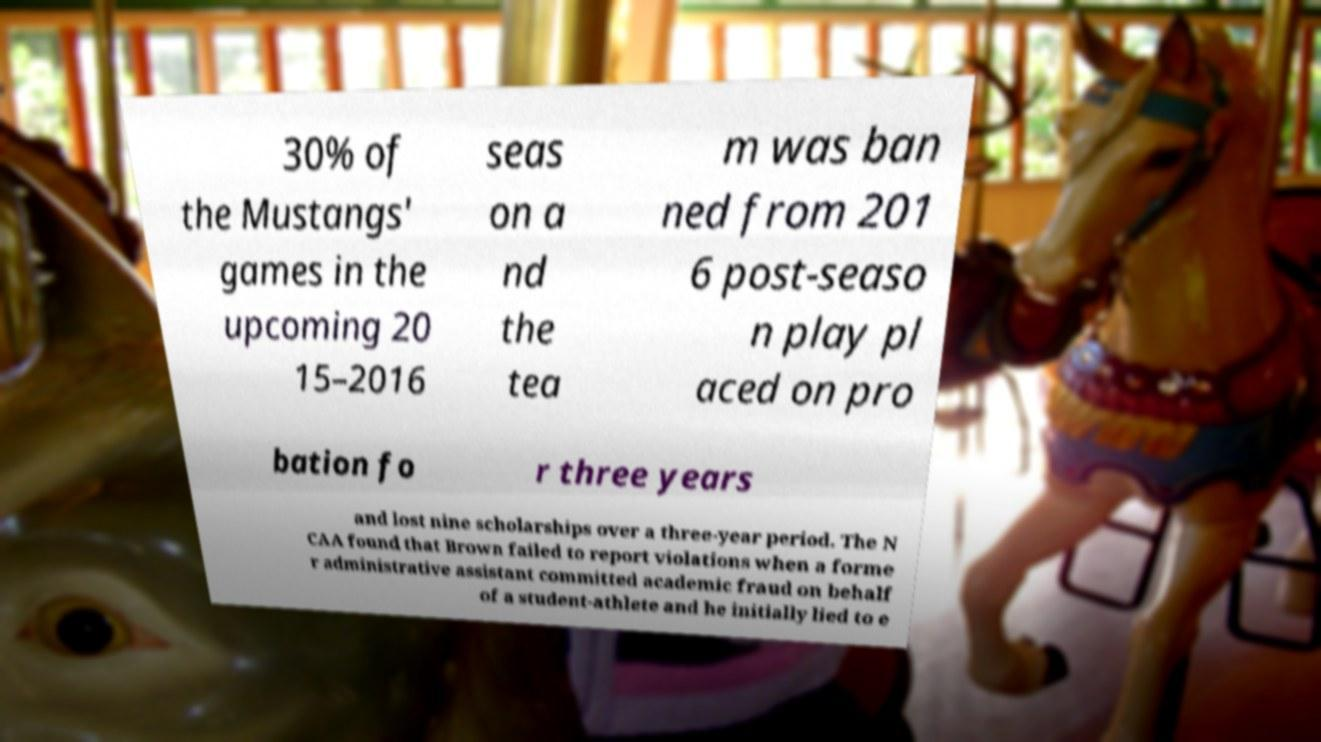There's text embedded in this image that I need extracted. Can you transcribe it verbatim? 30% of the Mustangs' games in the upcoming 20 15–2016 seas on a nd the tea m was ban ned from 201 6 post-seaso n play pl aced on pro bation fo r three years and lost nine scholarships over a three-year period. The N CAA found that Brown failed to report violations when a forme r administrative assistant committed academic fraud on behalf of a student-athlete and he initially lied to e 